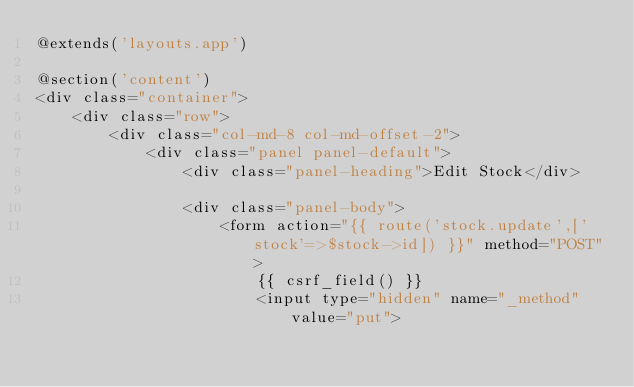<code> <loc_0><loc_0><loc_500><loc_500><_PHP_>@extends('layouts.app')

@section('content')
<div class="container">
	<div class="row">
		<div class="col-md-8 col-md-offset-2">
            <div class="panel panel-default">
                <div class="panel-heading">Edit Stock</div>

                <div class="panel-body">
                	<form action="{{ route('stock.update',['stock'=>$stock->id]) }}" method="POST">
                		{{ csrf_field() }}
                		<input type="hidden" name="_method" value="put"></code> 